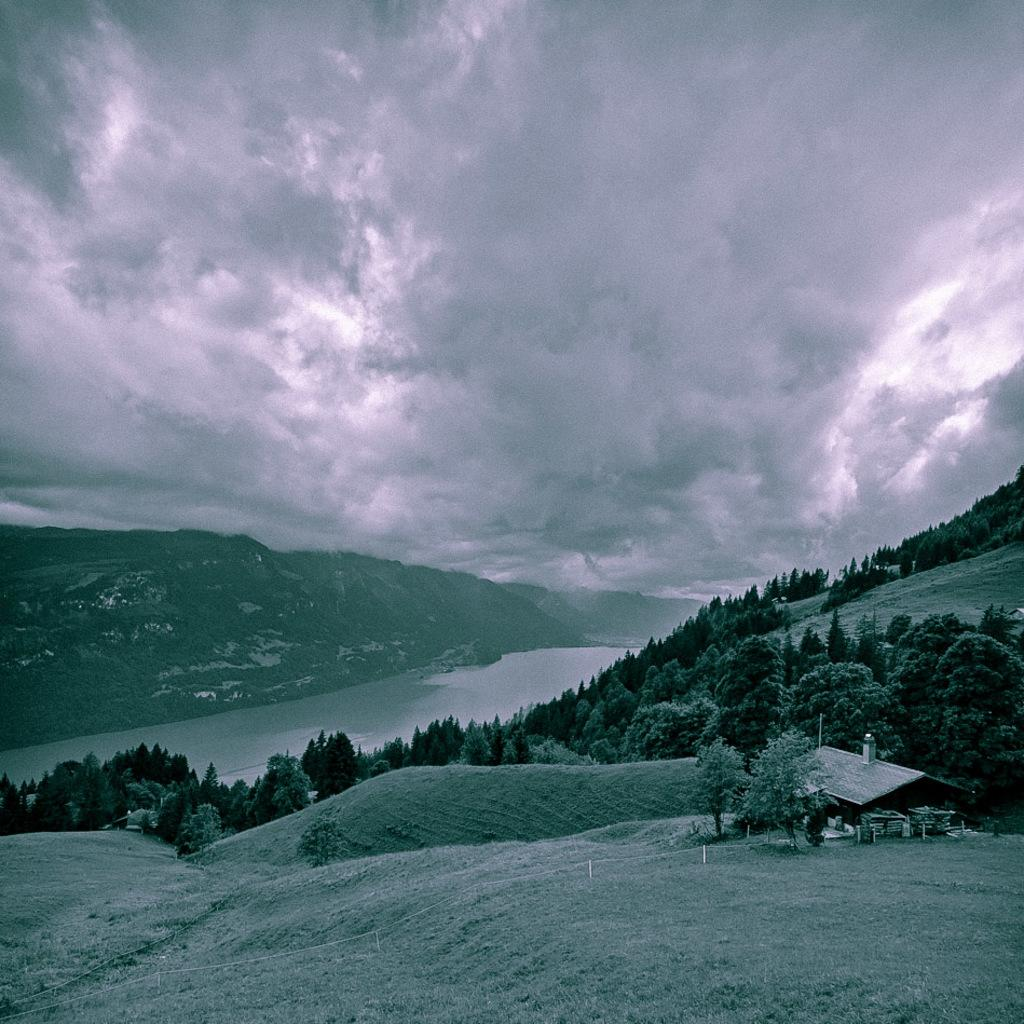What is the main feature in the center of the image? There is a river in the center of the image. What can be seen at the bottom of the image? There are trees at the bottom of the image. What type of structure is visible in the image? There is a shed visible in the image. What is visible in the background of the image? There are hills and the sky visible in the background of the image. Where is the jewel hidden in the image? There is no jewel present in the image. Can you see a nest in any of the trees in the image? There is no nest visible in the trees in the image. 